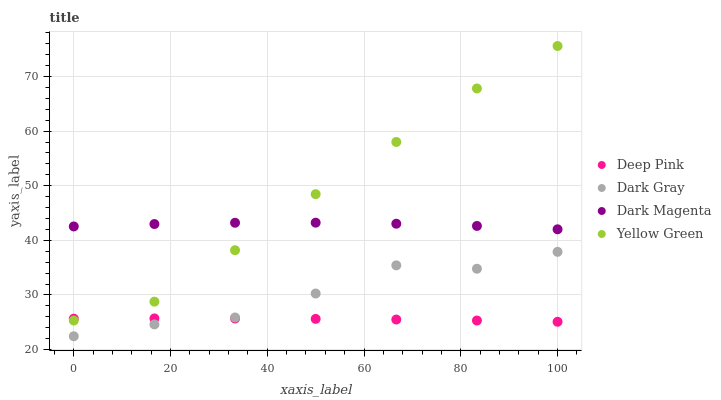Does Deep Pink have the minimum area under the curve?
Answer yes or no. Yes. Does Yellow Green have the maximum area under the curve?
Answer yes or no. Yes. Does Dark Magenta have the minimum area under the curve?
Answer yes or no. No. Does Dark Magenta have the maximum area under the curve?
Answer yes or no. No. Is Deep Pink the smoothest?
Answer yes or no. Yes. Is Dark Gray the roughest?
Answer yes or no. Yes. Is Dark Magenta the smoothest?
Answer yes or no. No. Is Dark Magenta the roughest?
Answer yes or no. No. Does Dark Gray have the lowest value?
Answer yes or no. Yes. Does Deep Pink have the lowest value?
Answer yes or no. No. Does Yellow Green have the highest value?
Answer yes or no. Yes. Does Dark Magenta have the highest value?
Answer yes or no. No. Is Dark Gray less than Yellow Green?
Answer yes or no. Yes. Is Yellow Green greater than Dark Gray?
Answer yes or no. Yes. Does Dark Gray intersect Deep Pink?
Answer yes or no. Yes. Is Dark Gray less than Deep Pink?
Answer yes or no. No. Is Dark Gray greater than Deep Pink?
Answer yes or no. No. Does Dark Gray intersect Yellow Green?
Answer yes or no. No. 